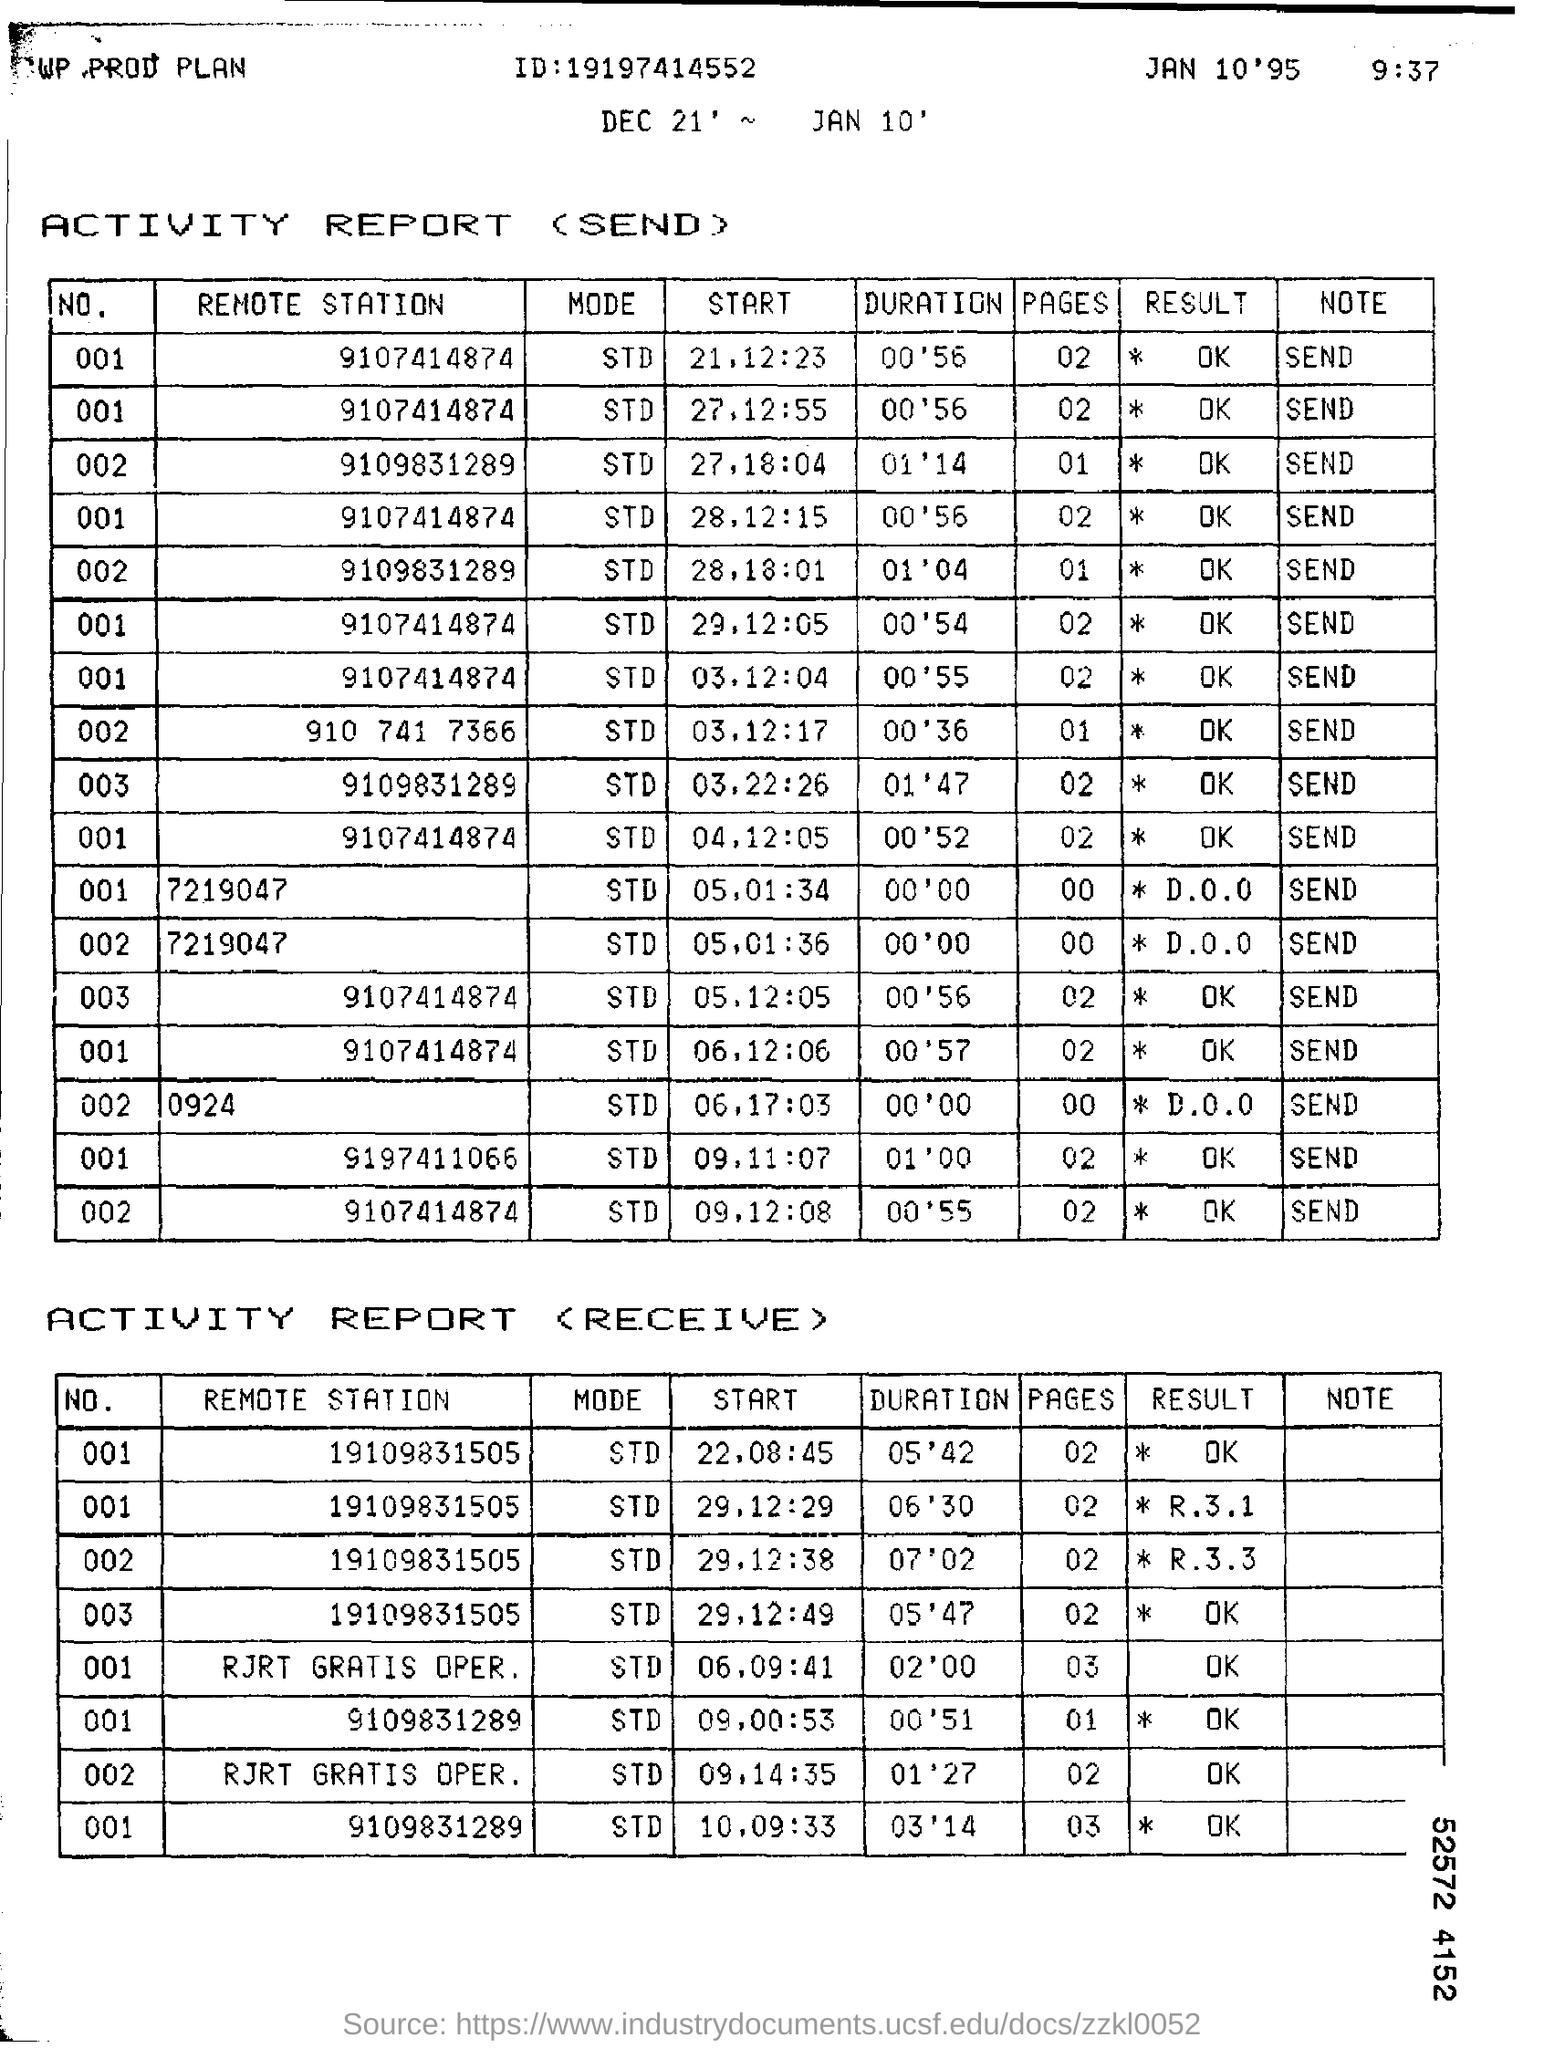Mention a couple of crucial points in this snapshot. The result for the remote station 9107414874 is "OK. 